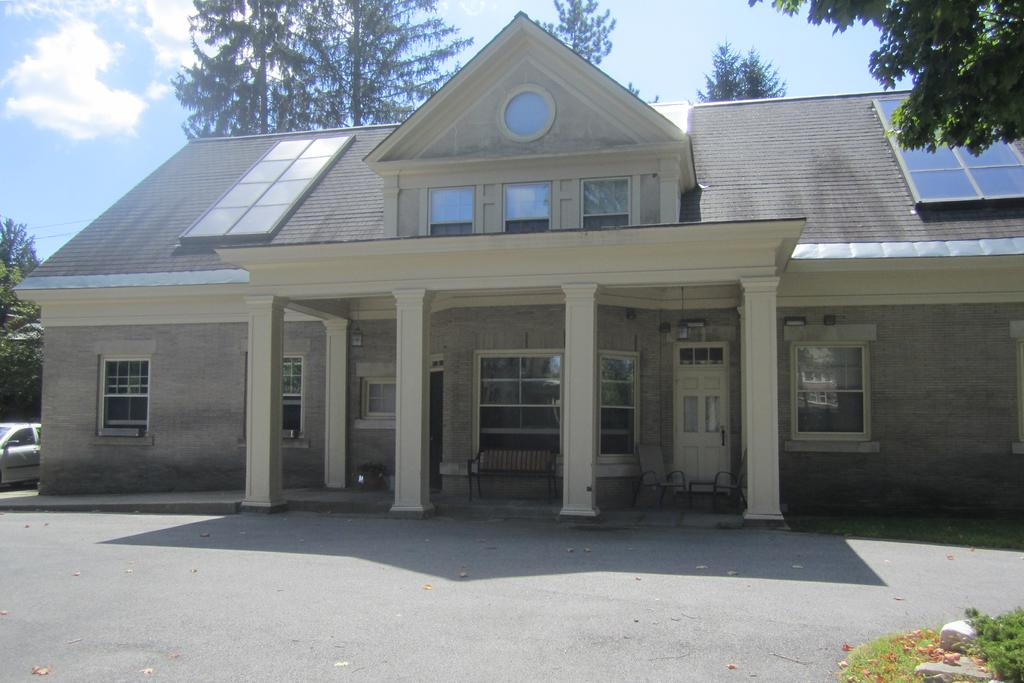What type of building is in the image? There is a beautiful house in the image. Is there any vehicle visible near the house? Yes, there is a car beside the house. What can be seen in the surroundings of the house? There are trees around the house. How much powder is needed to fill the car in the image? There is no mention of powder in the image, and it is not possible to fill a car with powder. 